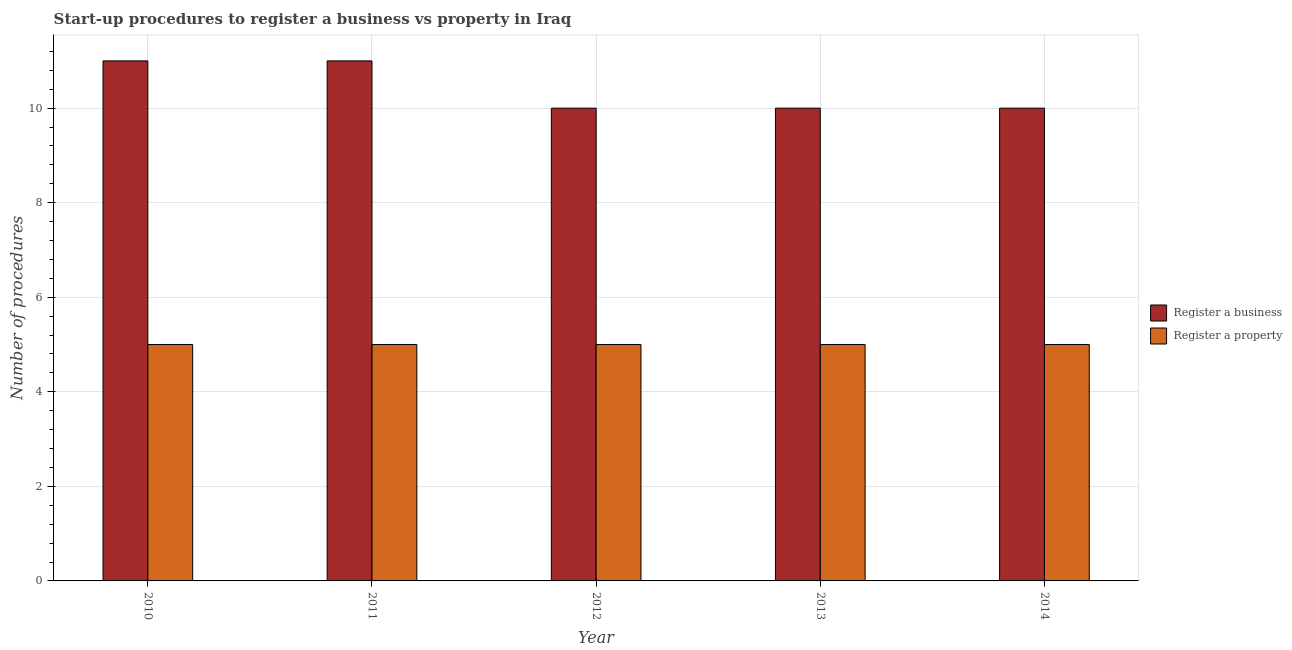How many bars are there on the 3rd tick from the left?
Your answer should be very brief. 2. How many bars are there on the 4th tick from the right?
Offer a very short reply. 2. In how many cases, is the number of bars for a given year not equal to the number of legend labels?
Provide a short and direct response. 0. What is the number of procedures to register a property in 2012?
Make the answer very short. 5. Across all years, what is the maximum number of procedures to register a business?
Your response must be concise. 11. Across all years, what is the minimum number of procedures to register a property?
Provide a short and direct response. 5. What is the total number of procedures to register a property in the graph?
Give a very brief answer. 25. What is the difference between the number of procedures to register a property in 2011 and the number of procedures to register a business in 2014?
Give a very brief answer. 0. Is the difference between the number of procedures to register a business in 2010 and 2014 greater than the difference between the number of procedures to register a property in 2010 and 2014?
Provide a succinct answer. No. What is the difference between the highest and the second highest number of procedures to register a business?
Your answer should be compact. 0. What is the difference between the highest and the lowest number of procedures to register a business?
Make the answer very short. 1. What does the 1st bar from the left in 2010 represents?
Ensure brevity in your answer.  Register a business. What does the 1st bar from the right in 2013 represents?
Give a very brief answer. Register a property. How many years are there in the graph?
Make the answer very short. 5. Does the graph contain any zero values?
Provide a succinct answer. No. How are the legend labels stacked?
Ensure brevity in your answer.  Vertical. What is the title of the graph?
Provide a succinct answer. Start-up procedures to register a business vs property in Iraq. What is the label or title of the Y-axis?
Make the answer very short. Number of procedures. What is the Number of procedures in Register a business in 2010?
Your response must be concise. 11. What is the Number of procedures of Register a property in 2011?
Offer a terse response. 5. What is the Number of procedures of Register a business in 2012?
Make the answer very short. 10. What is the Number of procedures of Register a property in 2012?
Your response must be concise. 5. What is the Number of procedures of Register a business in 2013?
Your answer should be very brief. 10. What is the Number of procedures of Register a property in 2014?
Your response must be concise. 5. Across all years, what is the maximum Number of procedures of Register a business?
Your answer should be very brief. 11. Across all years, what is the minimum Number of procedures of Register a business?
Make the answer very short. 10. Across all years, what is the minimum Number of procedures of Register a property?
Your response must be concise. 5. What is the total Number of procedures of Register a business in the graph?
Your answer should be very brief. 52. What is the total Number of procedures in Register a property in the graph?
Make the answer very short. 25. What is the difference between the Number of procedures in Register a business in 2010 and that in 2011?
Offer a terse response. 0. What is the difference between the Number of procedures in Register a business in 2010 and that in 2014?
Your answer should be compact. 1. What is the difference between the Number of procedures of Register a property in 2010 and that in 2014?
Your answer should be very brief. 0. What is the difference between the Number of procedures of Register a property in 2011 and that in 2014?
Give a very brief answer. 0. What is the difference between the Number of procedures in Register a business in 2013 and that in 2014?
Your answer should be compact. 0. What is the difference between the Number of procedures in Register a business in 2010 and the Number of procedures in Register a property in 2013?
Your response must be concise. 6. What is the difference between the Number of procedures of Register a business in 2010 and the Number of procedures of Register a property in 2014?
Offer a terse response. 6. What is the difference between the Number of procedures of Register a business in 2011 and the Number of procedures of Register a property in 2013?
Give a very brief answer. 6. What is the difference between the Number of procedures in Register a business in 2011 and the Number of procedures in Register a property in 2014?
Your response must be concise. 6. What is the average Number of procedures of Register a property per year?
Ensure brevity in your answer.  5. In the year 2011, what is the difference between the Number of procedures of Register a business and Number of procedures of Register a property?
Your answer should be very brief. 6. In the year 2013, what is the difference between the Number of procedures in Register a business and Number of procedures in Register a property?
Your answer should be very brief. 5. What is the ratio of the Number of procedures in Register a business in 2010 to that in 2011?
Provide a short and direct response. 1. What is the ratio of the Number of procedures in Register a property in 2010 to that in 2011?
Your answer should be compact. 1. What is the ratio of the Number of procedures of Register a property in 2010 to that in 2013?
Keep it short and to the point. 1. What is the ratio of the Number of procedures of Register a business in 2010 to that in 2014?
Make the answer very short. 1.1. What is the ratio of the Number of procedures in Register a property in 2010 to that in 2014?
Provide a succinct answer. 1. What is the ratio of the Number of procedures in Register a business in 2011 to that in 2012?
Offer a very short reply. 1.1. What is the ratio of the Number of procedures of Register a property in 2011 to that in 2012?
Offer a very short reply. 1. What is the ratio of the Number of procedures of Register a property in 2011 to that in 2013?
Give a very brief answer. 1. What is the ratio of the Number of procedures in Register a business in 2011 to that in 2014?
Your response must be concise. 1.1. What is the ratio of the Number of procedures in Register a property in 2011 to that in 2014?
Offer a terse response. 1. What is the ratio of the Number of procedures of Register a business in 2012 to that in 2013?
Ensure brevity in your answer.  1. What is the ratio of the Number of procedures of Register a business in 2012 to that in 2014?
Keep it short and to the point. 1. What is the ratio of the Number of procedures in Register a business in 2013 to that in 2014?
Ensure brevity in your answer.  1. What is the ratio of the Number of procedures of Register a property in 2013 to that in 2014?
Your answer should be very brief. 1. What is the difference between the highest and the second highest Number of procedures of Register a property?
Give a very brief answer. 0. What is the difference between the highest and the lowest Number of procedures of Register a property?
Your response must be concise. 0. 